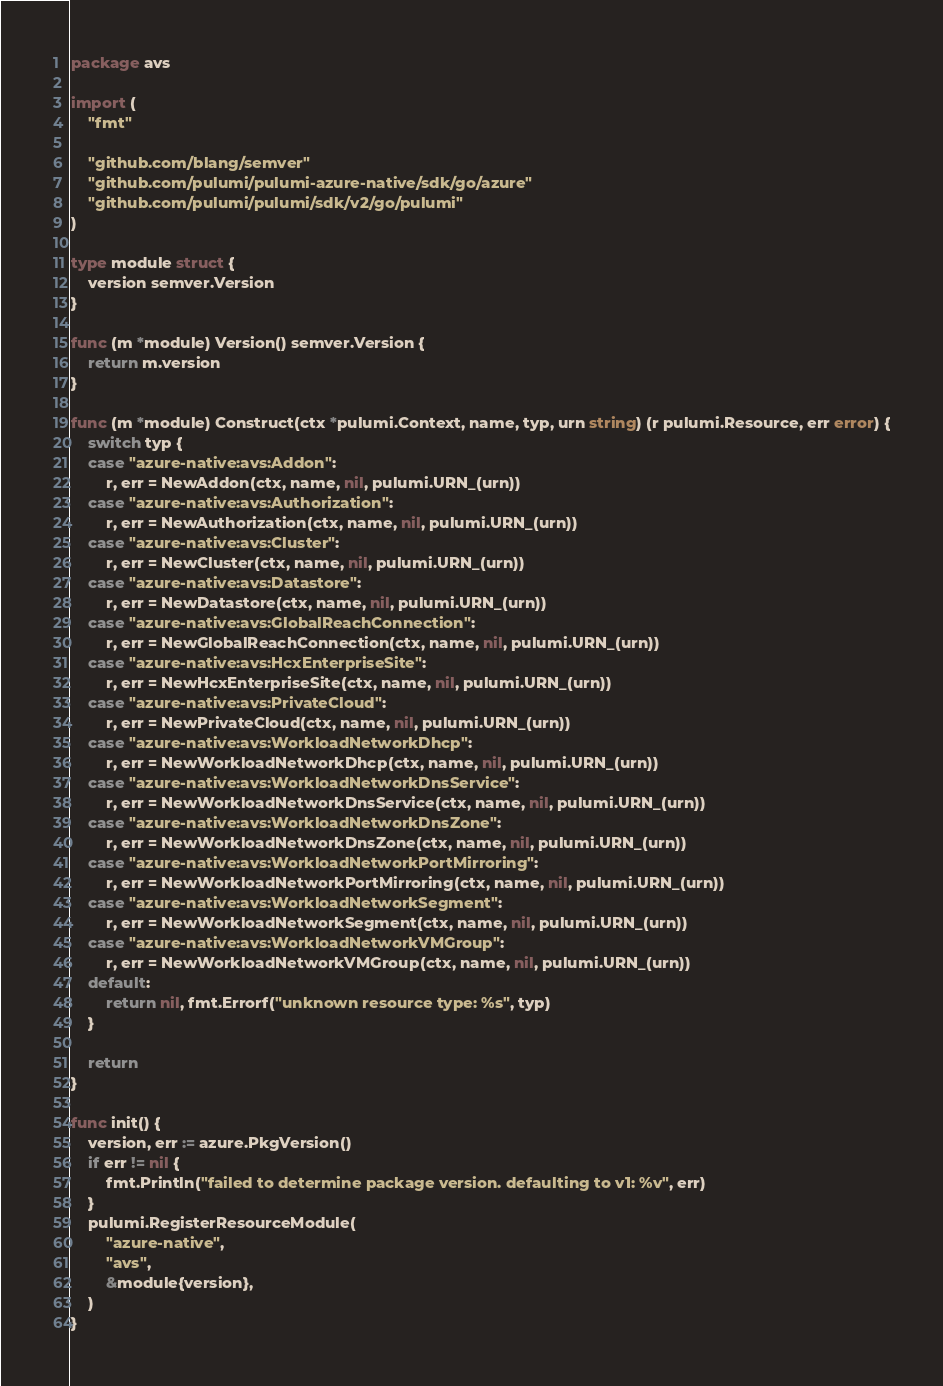Convert code to text. <code><loc_0><loc_0><loc_500><loc_500><_Go_>package avs

import (
	"fmt"

	"github.com/blang/semver"
	"github.com/pulumi/pulumi-azure-native/sdk/go/azure"
	"github.com/pulumi/pulumi/sdk/v2/go/pulumi"
)

type module struct {
	version semver.Version
}

func (m *module) Version() semver.Version {
	return m.version
}

func (m *module) Construct(ctx *pulumi.Context, name, typ, urn string) (r pulumi.Resource, err error) {
	switch typ {
	case "azure-native:avs:Addon":
		r, err = NewAddon(ctx, name, nil, pulumi.URN_(urn))
	case "azure-native:avs:Authorization":
		r, err = NewAuthorization(ctx, name, nil, pulumi.URN_(urn))
	case "azure-native:avs:Cluster":
		r, err = NewCluster(ctx, name, nil, pulumi.URN_(urn))
	case "azure-native:avs:Datastore":
		r, err = NewDatastore(ctx, name, nil, pulumi.URN_(urn))
	case "azure-native:avs:GlobalReachConnection":
		r, err = NewGlobalReachConnection(ctx, name, nil, pulumi.URN_(urn))
	case "azure-native:avs:HcxEnterpriseSite":
		r, err = NewHcxEnterpriseSite(ctx, name, nil, pulumi.URN_(urn))
	case "azure-native:avs:PrivateCloud":
		r, err = NewPrivateCloud(ctx, name, nil, pulumi.URN_(urn))
	case "azure-native:avs:WorkloadNetworkDhcp":
		r, err = NewWorkloadNetworkDhcp(ctx, name, nil, pulumi.URN_(urn))
	case "azure-native:avs:WorkloadNetworkDnsService":
		r, err = NewWorkloadNetworkDnsService(ctx, name, nil, pulumi.URN_(urn))
	case "azure-native:avs:WorkloadNetworkDnsZone":
		r, err = NewWorkloadNetworkDnsZone(ctx, name, nil, pulumi.URN_(urn))
	case "azure-native:avs:WorkloadNetworkPortMirroring":
		r, err = NewWorkloadNetworkPortMirroring(ctx, name, nil, pulumi.URN_(urn))
	case "azure-native:avs:WorkloadNetworkSegment":
		r, err = NewWorkloadNetworkSegment(ctx, name, nil, pulumi.URN_(urn))
	case "azure-native:avs:WorkloadNetworkVMGroup":
		r, err = NewWorkloadNetworkVMGroup(ctx, name, nil, pulumi.URN_(urn))
	default:
		return nil, fmt.Errorf("unknown resource type: %s", typ)
	}

	return
}

func init() {
	version, err := azure.PkgVersion()
	if err != nil {
		fmt.Println("failed to determine package version. defaulting to v1: %v", err)
	}
	pulumi.RegisterResourceModule(
		"azure-native",
		"avs",
		&module{version},
	)
}
</code> 